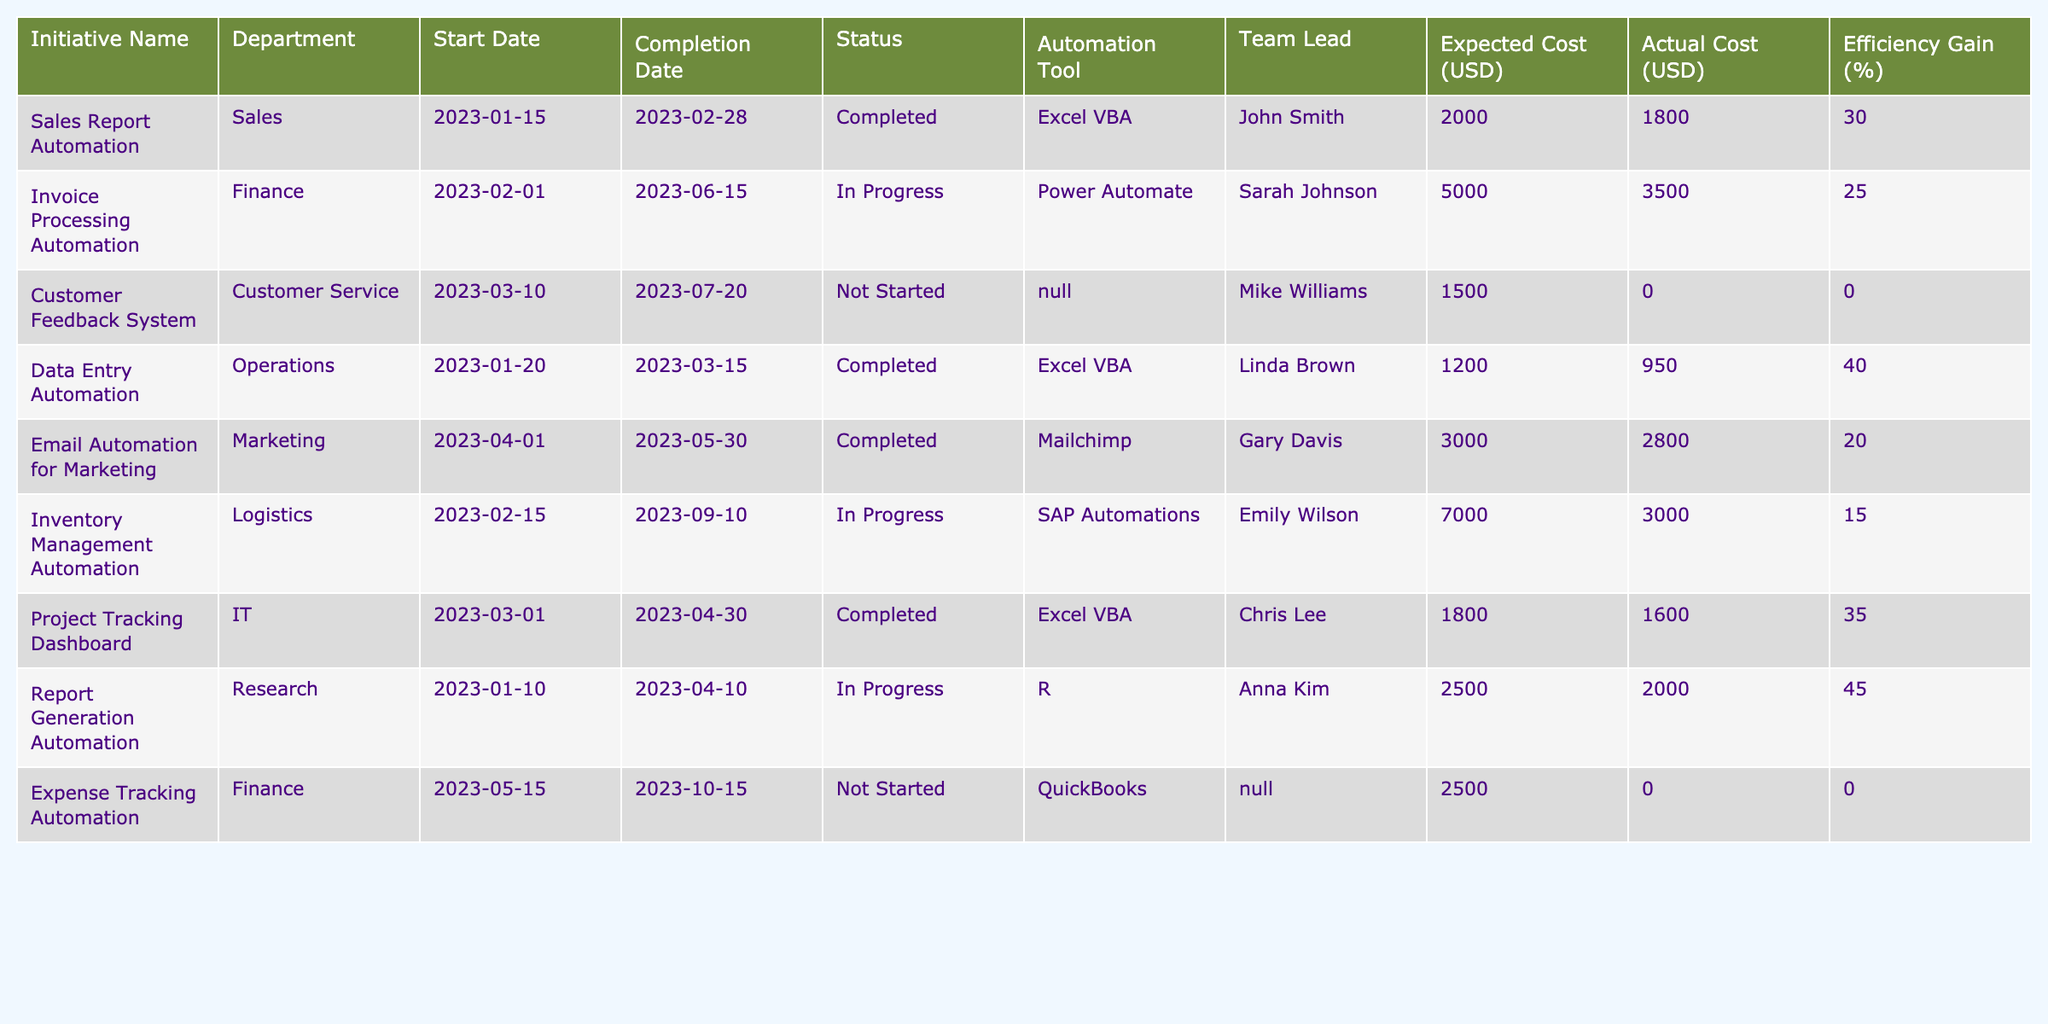What is the status of the "Customer Feedback System" initiative? The table shows the "Customer Feedback System" initiative under the Status column as "Not Started."
Answer: Not Started Which department is responsible for the "Report Generation Automation"? The table indicates that the "Report Generation Automation" initiative belongs to the Research department.
Answer: Research What is the expected cost of the "Invoice Processing Automation"? The expected cost is listed in the Expected Cost (USD) column as 5000.
Answer: 5000 What is the difference between the actual cost and the expected cost for the "Project Tracking Dashboard"? The expected cost is 1800 and the actual cost is 1600, so the difference is 1800 - 1600 = 200.
Answer: 200 How many initiatives are marked as "In Progress"? By counting the initiatives with the status "In Progress" in the table, there are three: "Invoice Processing Automation," "Inventory Management Automation," and "Report Generation Automation."
Answer: 3 What percentage of efficiency gain did the completed "Email Automation for Marketing" achieve? The table shows the efficiency gain percentage for the "Email Automation for Marketing" as 20%.
Answer: 20% What is the average expected cost of all "Completed" initiatives? The expected costs for completed initiatives are 2000 (Sales) + 1200 (Data Entry) + 3000 (Email) + 1800 (Project Tracking) = 8000. Since there are four completed initiatives, the average is 8000 / 4 = 2000.
Answer: 2000 Is the "Expense Tracking Automation" initiative currently underway? The table lists the status of "Expense Tracking Automation" as "Not Started," which means it is not underway.
Answer: No Which initiative has the highest efficiency gain, and what is that percentage? By reviewing the Efficiency Gain (%) column, the "Report Generation Automation" initiative has the highest efficiency gain at 45%.
Answer: Report Generation Automation, 45% What is the total expected cost of all initiatives in the Finance department? The expected costs for initiatives in the Finance department are 5000 (Invoice Processing) + 2500 (Expense Tracking) = 7500.
Answer: 7500 What is the minimum actual cost among all completed initiatives? The actual costs of completed initiatives are 1800 (Sales) + 950 (Data Entry) + 2800 (Email) + 1600 (Project Tracking). The minimum among these values is 950 from Data Entry Automation.
Answer: 950 What initiative was led by Chris Lee and what tool was used? The initiative led by Chris Lee is the "Project Tracking Dashboard," which used the Excel VBA tool.
Answer: Project Tracking Dashboard, Excel VBA 